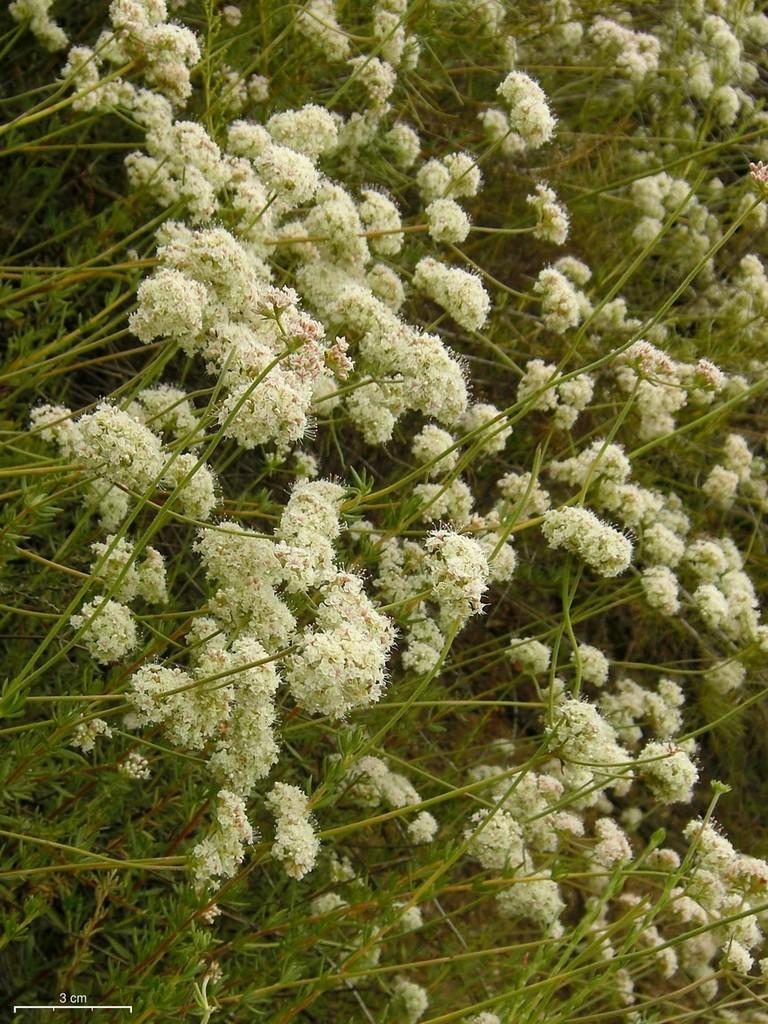What is the main subject of the image? The main subject of the image is a group of flowers. Can you describe the flowers' location in the image? The flowers are near plants in the image. What type of collar can be seen on the flowers in the image? There is no collar present on the flowers in the image. 